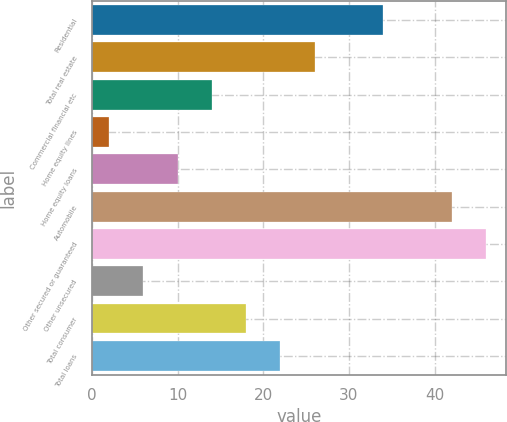Convert chart. <chart><loc_0><loc_0><loc_500><loc_500><bar_chart><fcel>Residential<fcel>Total real estate<fcel>Commercial financial etc<fcel>Home equity lines<fcel>Home equity loans<fcel>Automobile<fcel>Other secured or guaranteed<fcel>Other unsecured<fcel>Total consumer<fcel>Total loans<nl><fcel>34<fcel>26<fcel>14<fcel>2<fcel>10<fcel>42<fcel>46<fcel>6<fcel>18<fcel>22<nl></chart> 